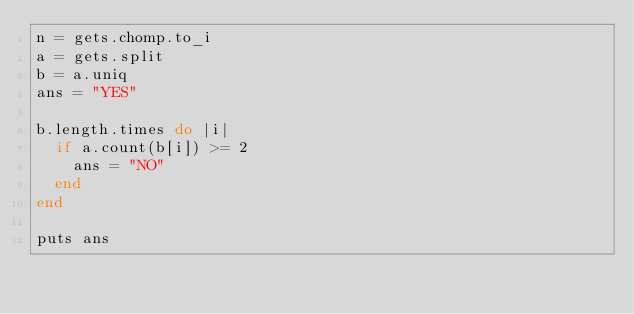<code> <loc_0><loc_0><loc_500><loc_500><_Ruby_>n = gets.chomp.to_i
a = gets.split
b = a.uniq
ans = "YES"

b.length.times do |i|
  if a.count(b[i]) >= 2
    ans = "NO"
  end
end

puts ans</code> 